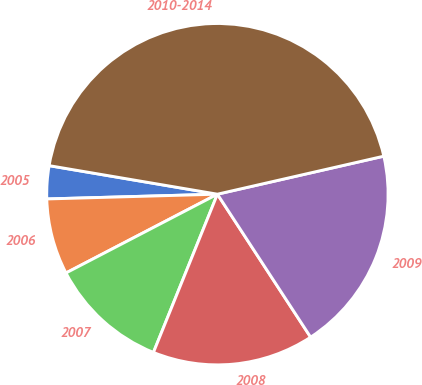Convert chart to OTSL. <chart><loc_0><loc_0><loc_500><loc_500><pie_chart><fcel>2005<fcel>2006<fcel>2007<fcel>2008<fcel>2009<fcel>2010-2014<nl><fcel>3.12%<fcel>7.19%<fcel>11.25%<fcel>15.31%<fcel>19.38%<fcel>43.75%<nl></chart> 